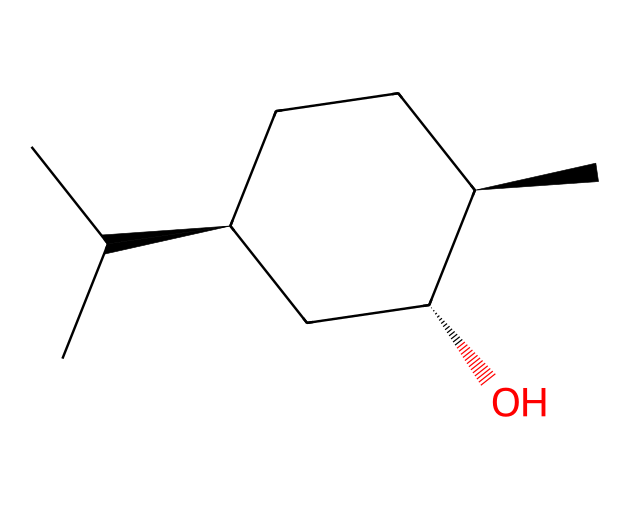What is the molecular formula of menthol? To determine the molecular formula, you count the number of each type of atom in the structure represented by the SMILES notation. This molecule has 10 carbon atoms, 20 hydrogen atoms, and 1 oxygen atom. Thus, the molecular formula is C10H20O.
Answer: C10H20O How many chiral centers are present in menthol? A chiral center is typically a carbon atom that is attached to four different substituents. By examining the structure from the SMILES, we can identify two carbon atoms that have four different groups connected to them, indicating the presence of two chiral centers.
Answer: 2 What type of compound is menthol classified as? Menthol is identified in this structure due to its carbon and hydroxyl groups (-OH), indicating that it's a type of alcohol. Given its aliphatic carbon structure with no aromatic rings, it's classified as a type of aliphatic compound.
Answer: alcohol What is the significance of the hydroxyl group in menthol's structure? The hydroxyl group (-OH) in menthol contributes to its properties as an alcohol, providing hydrogen bonding capabilities which enhance its solubility in water compared to non-polar compounds. This also affects the physical and chemical behavior of menthol in various applications, including in cricket balm.
Answer: hydrogen bonding How many rings are present in the menthol structure? The description of the SMILES indicates the presence of a ring structure due to the notation that includes numbers indicating where bonds connect. In this case, there is one cycloalkane ring present in menthol's structure.
Answer: 1 